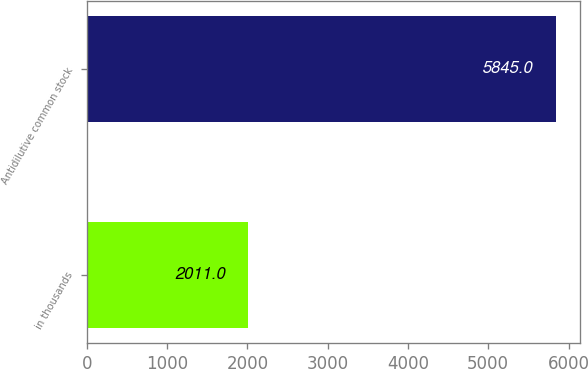Convert chart. <chart><loc_0><loc_0><loc_500><loc_500><bar_chart><fcel>in thousands<fcel>Antidilutive common stock<nl><fcel>2011<fcel>5845<nl></chart> 